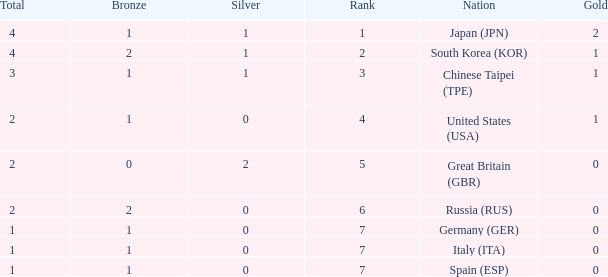What is the rank of the country with more than 2 medals, and 2 gold medals? 1.0. 